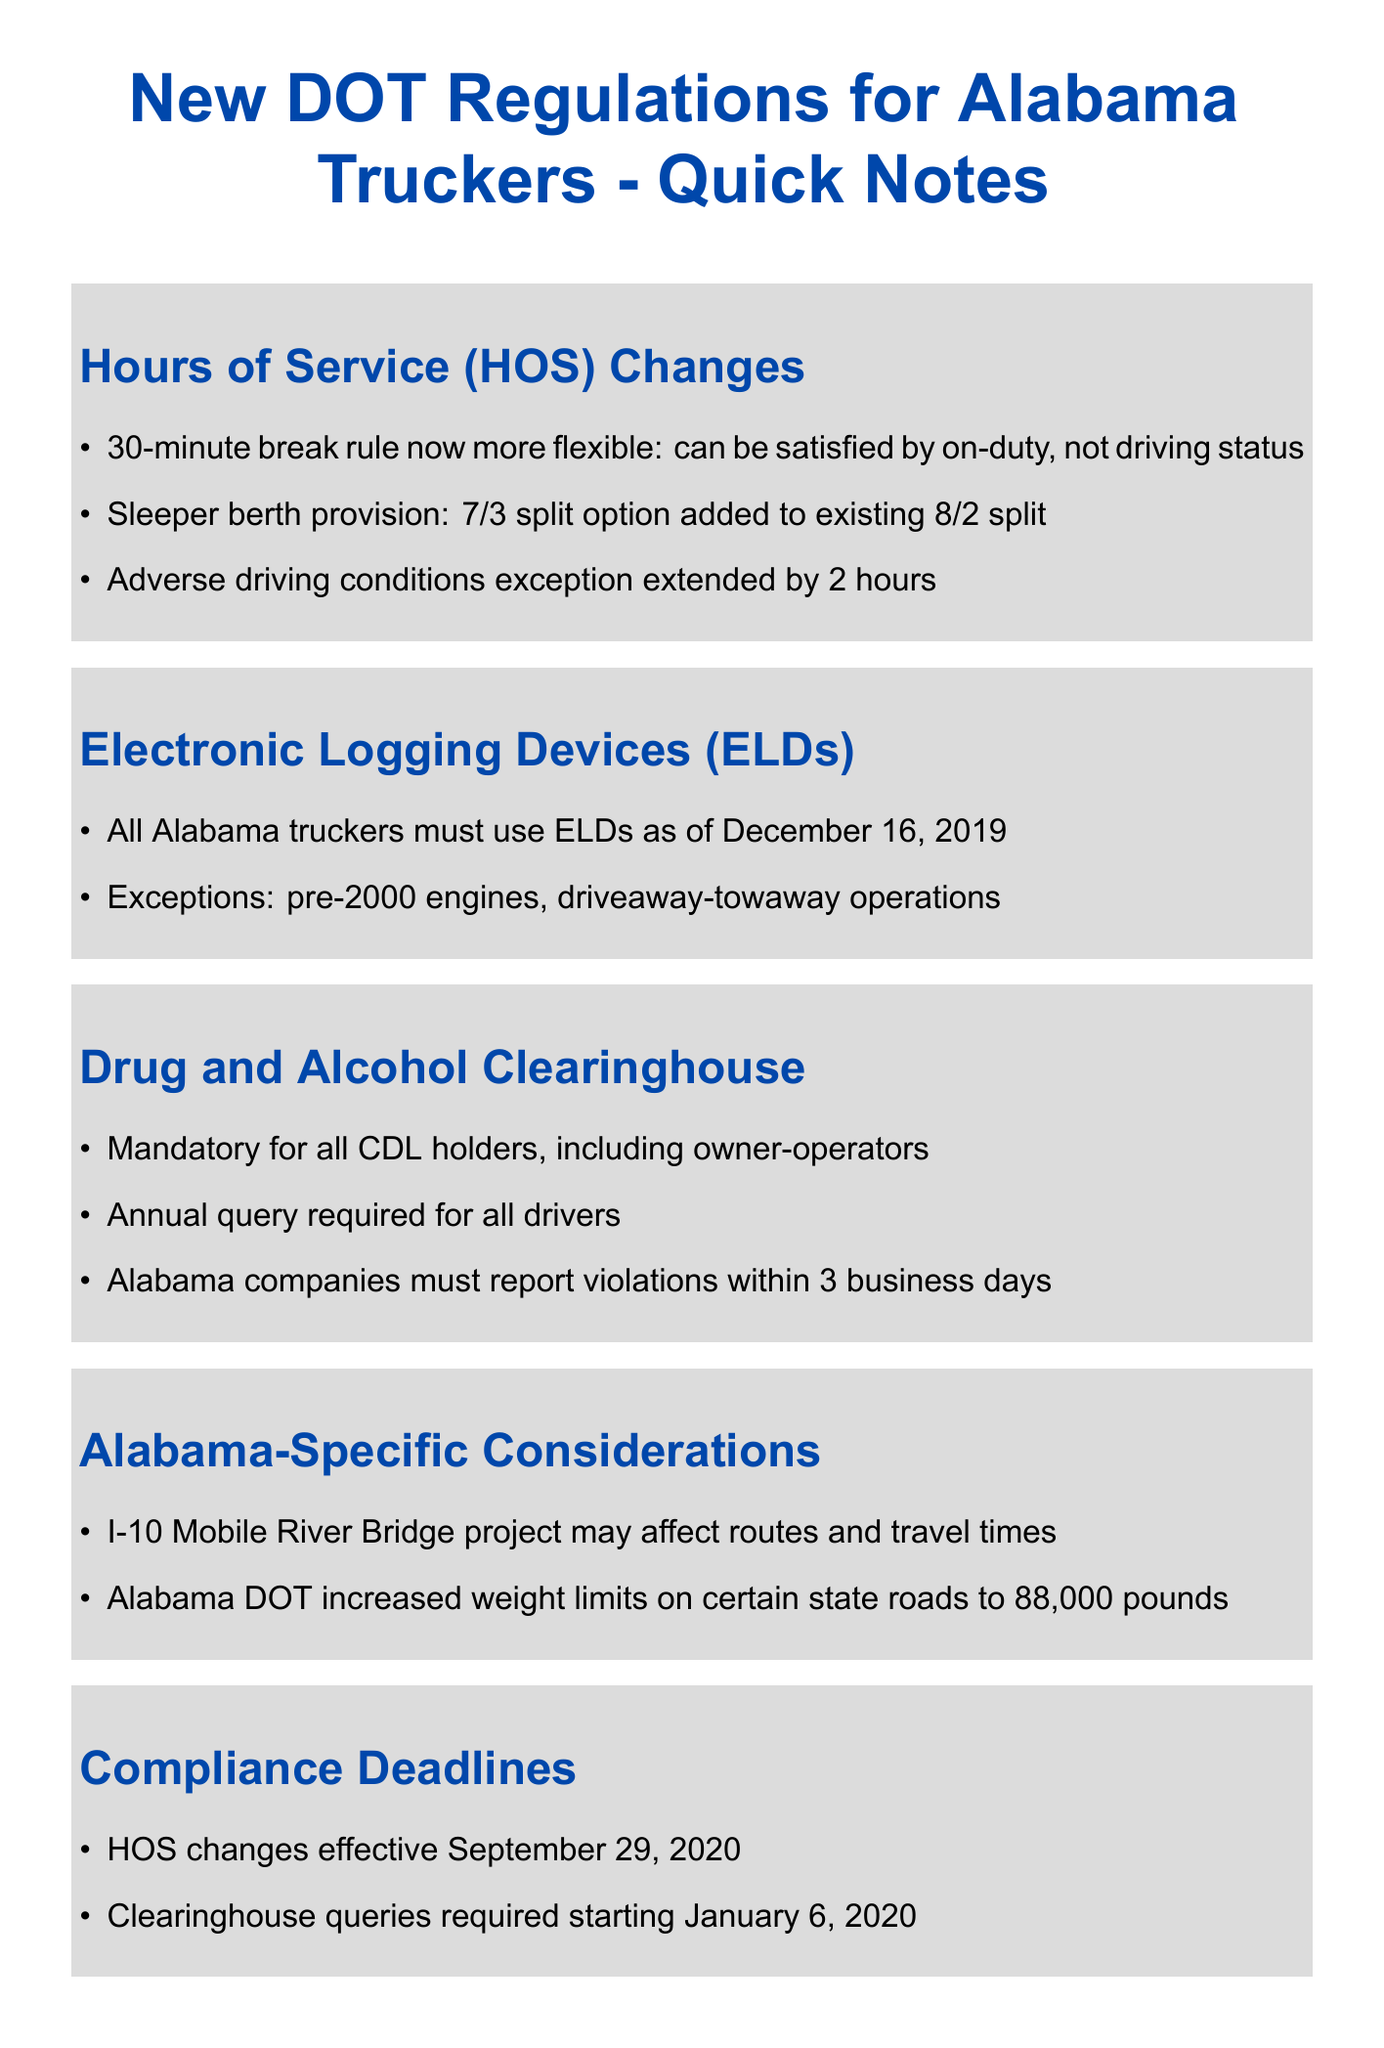What is the new flexibility in the 30-minute break rule? The 30-minute break can now be satisfied by on-duty, not driving status, providing more flexibility for drivers.
Answer: on-duty, not driving status What is the new sleeper berth provision? A 7/3 split option has been added to the existing 8/2 split for the sleeper berth provision.
Answer: 7/3 split When did the HOS changes become effective? The hours of service changes were effective starting September 29, 2020.
Answer: September 29, 2020 What is the weight limit increase on certain Alabama state roads? The Alabama DOT has increased weight limits to 88,000 pounds on certain state roads.
Answer: 88,000 pounds What must Alabama companies report within 3 business days? Alabama companies must report drug and alcohol violations within 3 business days as per the clearinghouse regulations.
Answer: violations Which trucks are exempt from using ELDs? Trucks with pre-2000 engines and those involved in driveaway-towaway operations are exempt from using ELDs.
Answer: pre-2000 engines, driveaway-towaway operations What is the deadline for mandatory clearinghouse queries? The clearinghouse queries became mandatory starting January 6, 2020.
Answer: January 6, 2020 How has the adverse driving conditions exception changed? The adverse driving conditions exception has been extended by 2 hours, allowing more time to adjust schedules during such conditions.
Answer: extended by 2 hours What additional resources are provided in the document? The document lists the Federal Motor Carrier Safety Administration (FMCSA) website and Alabama Trucking Association regulatory updates as additional resources.
Answer: FMCSA website, Alabama Trucking Association 